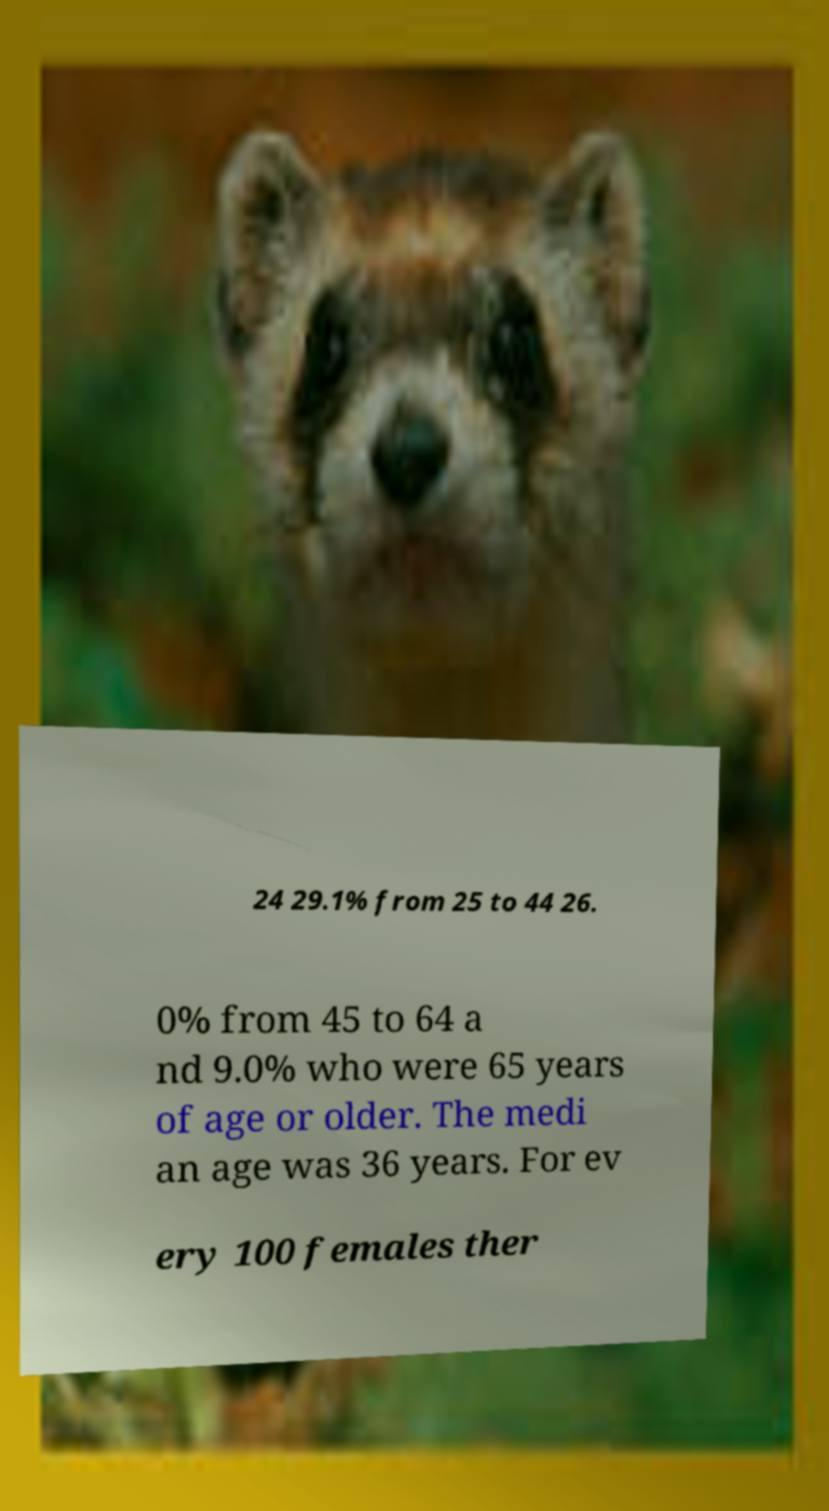Could you extract and type out the text from this image? 24 29.1% from 25 to 44 26. 0% from 45 to 64 a nd 9.0% who were 65 years of age or older. The medi an age was 36 years. For ev ery 100 females ther 